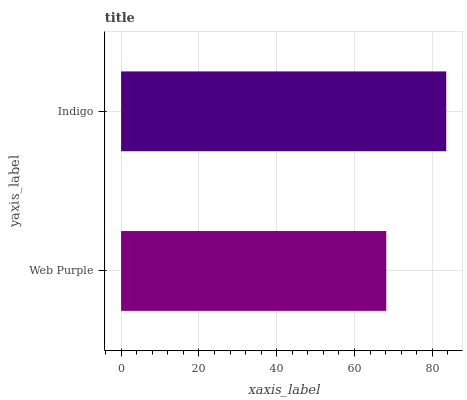Is Web Purple the minimum?
Answer yes or no. Yes. Is Indigo the maximum?
Answer yes or no. Yes. Is Indigo the minimum?
Answer yes or no. No. Is Indigo greater than Web Purple?
Answer yes or no. Yes. Is Web Purple less than Indigo?
Answer yes or no. Yes. Is Web Purple greater than Indigo?
Answer yes or no. No. Is Indigo less than Web Purple?
Answer yes or no. No. Is Indigo the high median?
Answer yes or no. Yes. Is Web Purple the low median?
Answer yes or no. Yes. Is Web Purple the high median?
Answer yes or no. No. Is Indigo the low median?
Answer yes or no. No. 